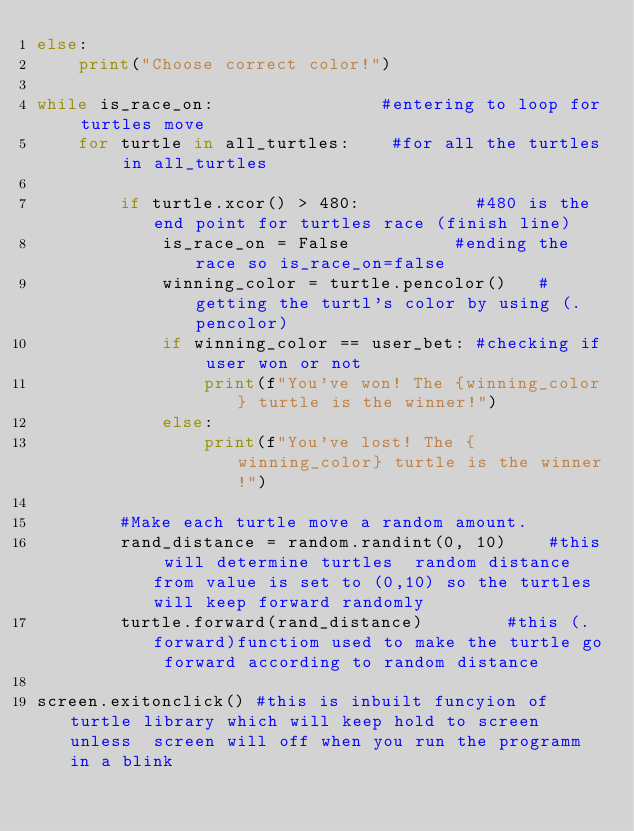Convert code to text. <code><loc_0><loc_0><loc_500><loc_500><_Python_>else:
    print("Choose correct color!")      

while is_race_on:                #entering to loop for turtles move
    for turtle in all_turtles:    #for all the turtles in all_turtles
        
        if turtle.xcor() > 480:           #480 is the end point for turtles race (finish line)
            is_race_on = False          #ending the race so is_race_on=false
            winning_color = turtle.pencolor()   #getting the turtl's color by using (.pencolor)
            if winning_color == user_bet: #checking if user won or not
                print(f"You've won! The {winning_color} turtle is the winner!")
            else:
                print(f"You've lost! The {winning_color} turtle is the winner!")

        #Make each turtle move a random amount.
        rand_distance = random.randint(0, 10)    #this will determine turtles  random distance from value is set to (0,10) so the turtles will keep forward randomly
        turtle.forward(rand_distance)        #this (.forward)functiom used to make the turtle go forward according to random distance

screen.exitonclick() #this is inbuilt funcyion of turtle library which will keep hold to screen unless  screen will off when you run the programm in a blink</code> 